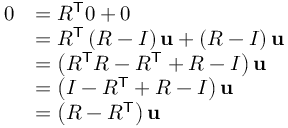Convert formula to latex. <formula><loc_0><loc_0><loc_500><loc_500>{ \begin{array} { r l } { 0 } & { = R ^ { T } 0 + 0 } \\ & { = R ^ { T } \left ( R - I \right ) u + \left ( R - I \right ) u } \\ & { = \left ( R ^ { T } R - R ^ { T } + R - I \right ) u } \\ & { = \left ( I - R ^ { T } + R - I \right ) u } \\ & { = \left ( R - R ^ { T } \right ) u } \end{array} }</formula> 